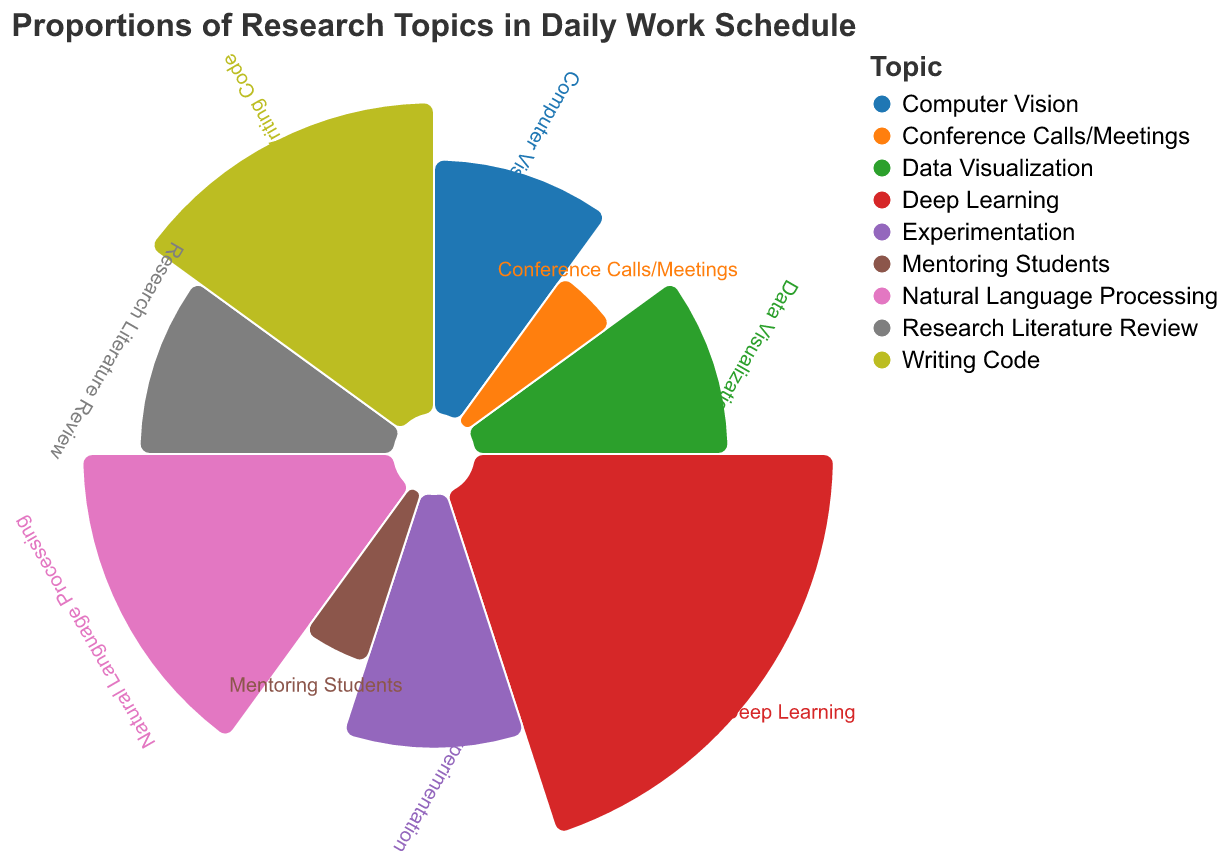What's the largest proportion among the research topics? The largest proportion can be identified by looking at the segment with the biggest area in the polar chart. The "Deep Learning" segment is the largest, occupying 20% of the schedule.
Answer: Deep Learning What's the combined proportion of time spent on "Natural Language Processing" and "Writing Code"? To find the combined proportion, add the proportions of "Natural Language Processing" (15%) and "Writing Code" (15%).
Answer: 30% Which topics have the same proportion of time allocated? Identify segments with equal-sized areas. "Computer Vision," "Data Visualization," "Research Literature Review," and "Experimentation" each have 10%. "Mentoring Students" and "Conference Calls/Meetings" each have 5%.
Answer: Computer Vision, Data Visualization, Research Literature Review, Experimentation; Mentoring Students, Conference Calls/Meetings How much more time is spent on "Deep Learning" compared to "Mentoring Students"? Subtract the proportion of "Mentoring Students" (5%) from the proportion of "Deep Learning" (20%).
Answer: 15% What's the sum of the proportions of the least two time-consuming activities? "Mentoring Students" and "Conference Calls/Meetings" both occupy 5%, so their total is 5% + 5%.
Answer: 10% What's the proportion of time spent on research activities (Deep Learning, NLP, Computer Vision, Data Visualization, Research Literature Review)? Add the proportions of each research activity: 20% (Deep Learning) + 15% (NLP) + 10% (Computer Vision) + 10% (Data Visualization) + 10% (Research Literature Review).
Answer: 65% Which activity has a larger proportion, "Experimentation" or "Mentoring Students"? By comparing the sizes visually, "Experimentation" has 10%, more than "Mentoring Students" at 5%.
Answer: Experimentation If we categorize the topics into "Coding" and "Non-Coding," what's the proportion of coding-related topics? "Coding" includes "Writing Code" and possibly "Experimentation." Add their proportions: 15% (Writing Code) + 10% (Experimentation).
Answer: 25% How many research topics make up more than 10% of the schedule? Identify and count the topics with proportions over 10%: "Deep Learning" (20%), "NLP" (15%), "Writing Code" (15%).
Answer: 3 How does the time spent on "Conference Calls/Meetings" compare with "Data Visualization"? By comparing their segments, "Conference Calls/Meetings" has 5%, while "Data Visualization" has 10%, making the latter twice as much time-consuming.
Answer: Data Visualization is more 